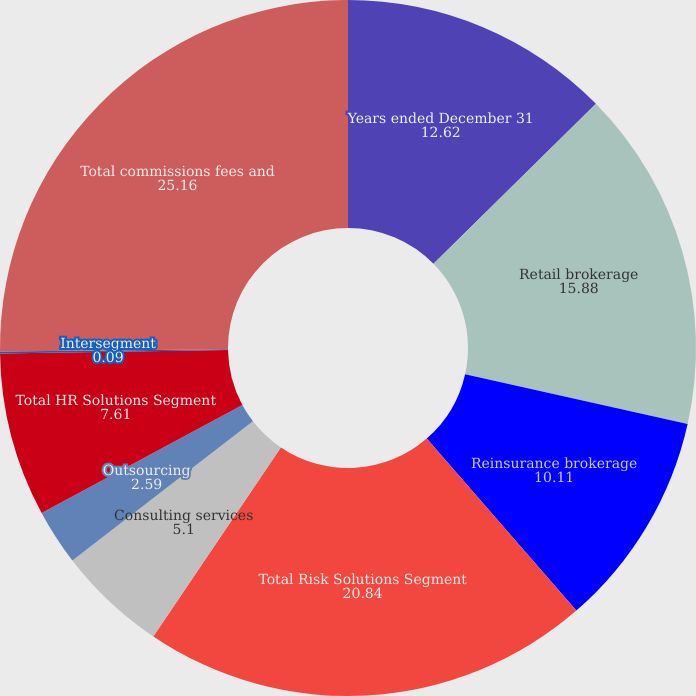Convert chart. <chart><loc_0><loc_0><loc_500><loc_500><pie_chart><fcel>Years ended December 31<fcel>Retail brokerage<fcel>Reinsurance brokerage<fcel>Total Risk Solutions Segment<fcel>Consulting services<fcel>Outsourcing<fcel>Total HR Solutions Segment<fcel>Intersegment<fcel>Total commissions fees and<nl><fcel>12.62%<fcel>15.88%<fcel>10.11%<fcel>20.84%<fcel>5.1%<fcel>2.59%<fcel>7.61%<fcel>0.09%<fcel>25.16%<nl></chart> 